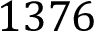<formula> <loc_0><loc_0><loc_500><loc_500>1 3 7 6</formula> 